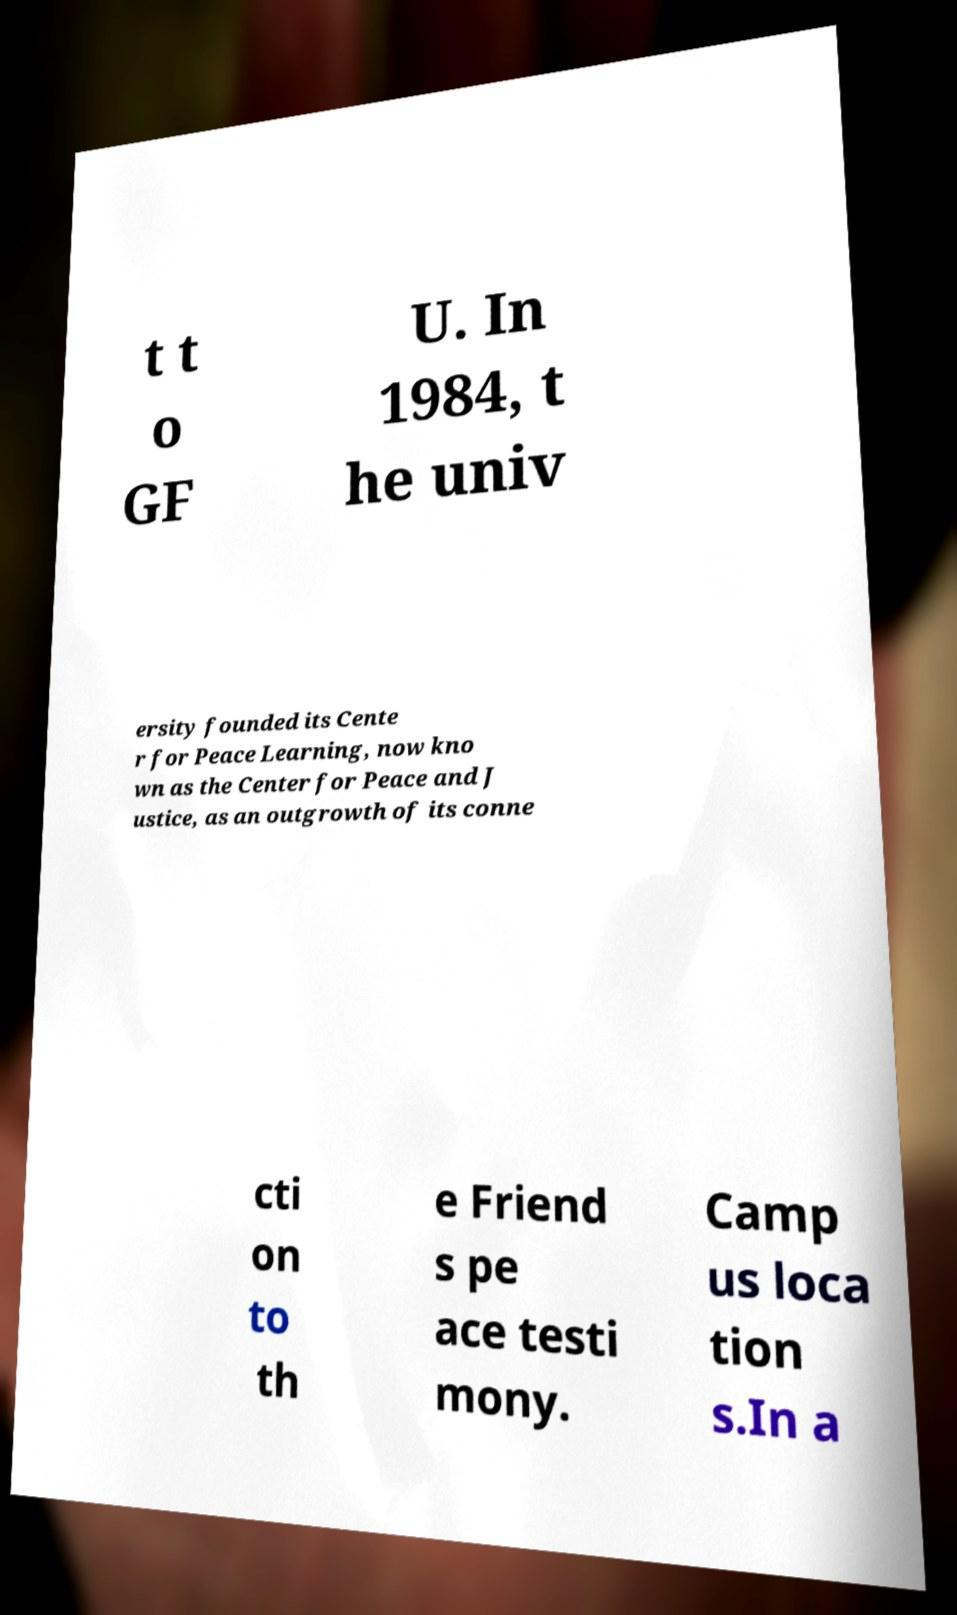For documentation purposes, I need the text within this image transcribed. Could you provide that? t t o GF U. In 1984, t he univ ersity founded its Cente r for Peace Learning, now kno wn as the Center for Peace and J ustice, as an outgrowth of its conne cti on to th e Friend s pe ace testi mony. Camp us loca tion s.In a 